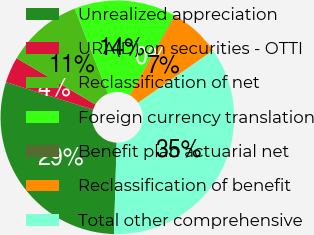Convert chart. <chart><loc_0><loc_0><loc_500><loc_500><pie_chart><fcel>Unrealized appreciation<fcel>URA(D) on securities - OTTI<fcel>Reclassification of net<fcel>Foreign currency translation<fcel>Benefit plan actuarial net<fcel>Reclassification of benefit<fcel>Total other comprehensive<nl><fcel>29.41%<fcel>3.58%<fcel>10.6%<fcel>14.1%<fcel>0.07%<fcel>7.09%<fcel>35.16%<nl></chart> 